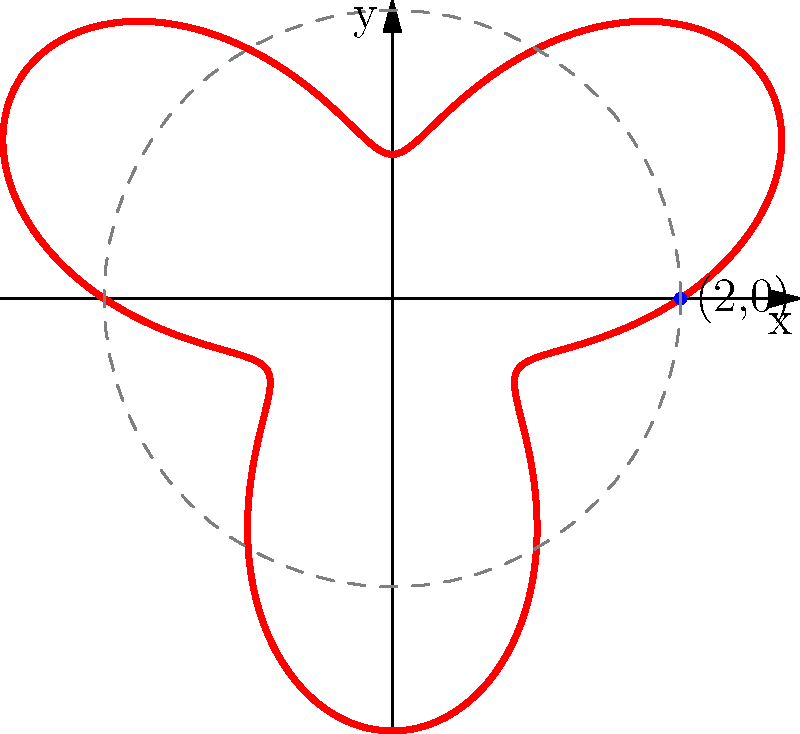Consider the polar curve given by the equation $r = 2 + \sin(3\theta)$, which represents the curvature of an expressive pencil stroke. What is the maximum radial distance of this curve from the origin? To find the maximum radial distance, we need to follow these steps:

1) The radial distance is given by $r = 2 + \sin(3\theta)$.

2) The $\sin$ function oscillates between -1 and 1.

3) When $\sin(3\theta)$ is at its maximum value of 1, $r$ will be at its maximum.

4) Therefore, the maximum value of $r$ occurs when $\sin(3\theta) = 1$.

5) At this point, $r_{max} = 2 + 1 = 3$.

6) We can verify this visually from the graph, where we see that the curve extends beyond the dashed circle with radius 2, but never reaches a radius of 4.

Thus, the maximum radial distance of the curve from the origin is 3 units.
Answer: 3 units 